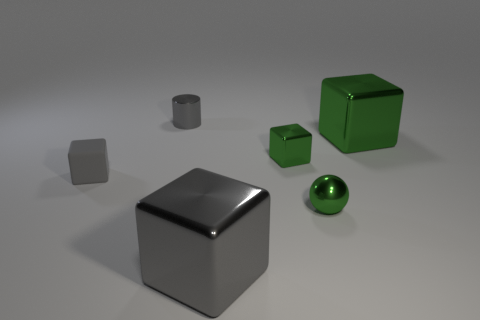Subtract all red cylinders. How many green blocks are left? 2 Add 4 big yellow cubes. How many objects exist? 10 Subtract all gray matte cubes. How many cubes are left? 3 Subtract all yellow blocks. Subtract all brown spheres. How many blocks are left? 4 Subtract all cylinders. How many objects are left? 5 Add 3 big metallic objects. How many big metallic objects are left? 5 Add 1 matte cubes. How many matte cubes exist? 2 Subtract 0 purple cylinders. How many objects are left? 6 Subtract all small rubber blocks. Subtract all large brown cubes. How many objects are left? 5 